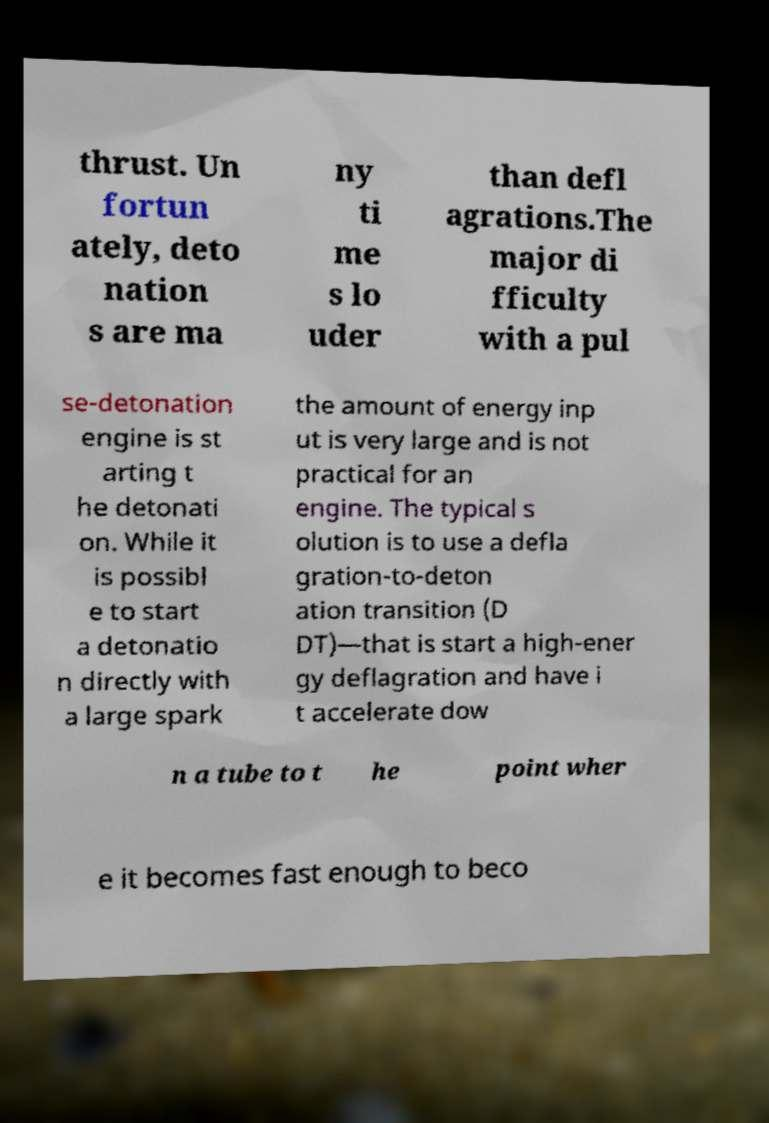Can you accurately transcribe the text from the provided image for me? thrust. Un fortun ately, deto nation s are ma ny ti me s lo uder than defl agrations.The major di fficulty with a pul se-detonation engine is st arting t he detonati on. While it is possibl e to start a detonatio n directly with a large spark the amount of energy inp ut is very large and is not practical for an engine. The typical s olution is to use a defla gration-to-deton ation transition (D DT)—that is start a high-ener gy deflagration and have i t accelerate dow n a tube to t he point wher e it becomes fast enough to beco 